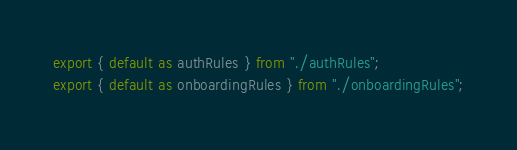<code> <loc_0><loc_0><loc_500><loc_500><_JavaScript_>export { default as authRules } from "./authRules";
export { default as onboardingRules } from "./onboardingRules";
</code> 